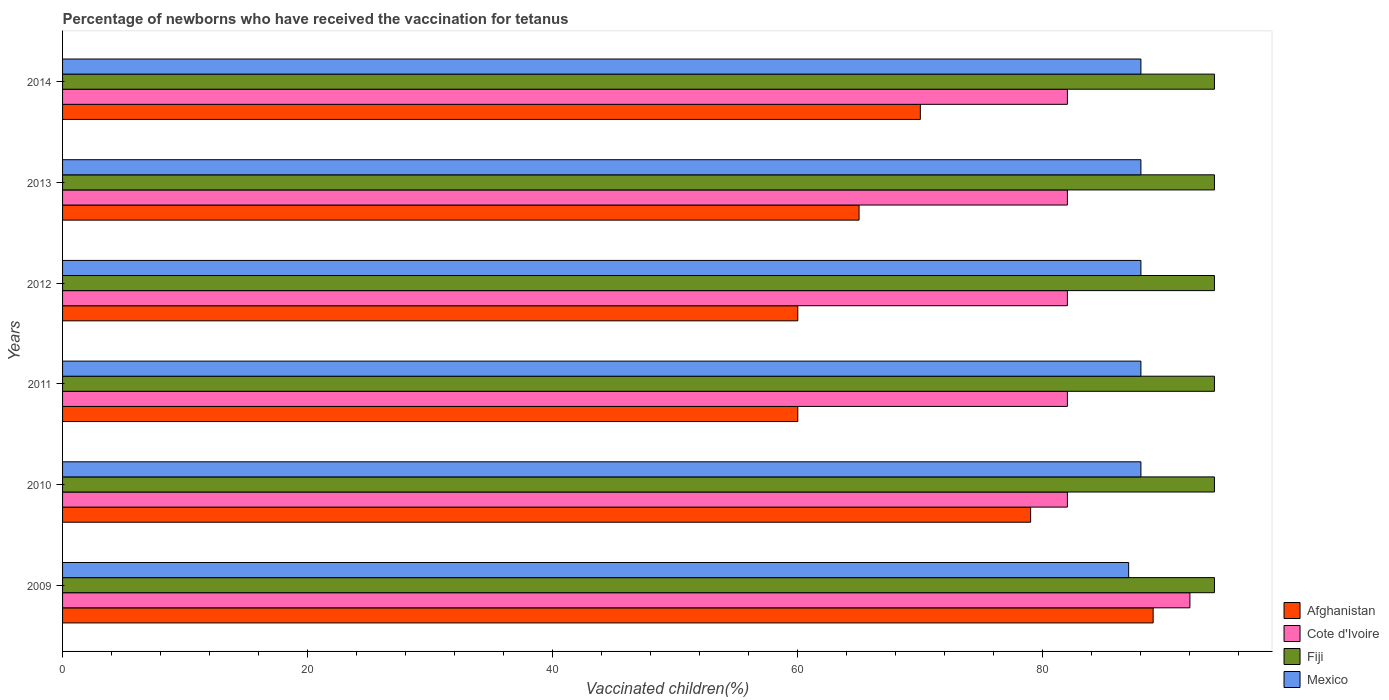What is the label of the 3rd group of bars from the top?
Give a very brief answer. 2012. What is the percentage of vaccinated children in Cote d'Ivoire in 2011?
Your response must be concise. 82. Across all years, what is the maximum percentage of vaccinated children in Cote d'Ivoire?
Keep it short and to the point. 92. What is the total percentage of vaccinated children in Mexico in the graph?
Provide a short and direct response. 527. What is the difference between the percentage of vaccinated children in Cote d'Ivoire in 2010 and that in 2012?
Give a very brief answer. 0. What is the difference between the percentage of vaccinated children in Cote d'Ivoire in 2014 and the percentage of vaccinated children in Mexico in 2013?
Make the answer very short. -6. What is the average percentage of vaccinated children in Afghanistan per year?
Your answer should be very brief. 70.5. In how many years, is the percentage of vaccinated children in Mexico greater than 64 %?
Provide a succinct answer. 6. What is the ratio of the percentage of vaccinated children in Mexico in 2009 to that in 2012?
Your response must be concise. 0.99. Is the percentage of vaccinated children in Fiji in 2009 less than that in 2011?
Make the answer very short. No. Is the difference between the percentage of vaccinated children in Afghanistan in 2010 and 2014 greater than the difference between the percentage of vaccinated children in Fiji in 2010 and 2014?
Provide a succinct answer. Yes. What is the difference between the highest and the second highest percentage of vaccinated children in Mexico?
Your answer should be compact. 0. Is the sum of the percentage of vaccinated children in Cote d'Ivoire in 2012 and 2013 greater than the maximum percentage of vaccinated children in Afghanistan across all years?
Your response must be concise. Yes. What does the 2nd bar from the top in 2009 represents?
Your response must be concise. Fiji. What does the 2nd bar from the bottom in 2013 represents?
Make the answer very short. Cote d'Ivoire. Are the values on the major ticks of X-axis written in scientific E-notation?
Keep it short and to the point. No. Does the graph contain any zero values?
Make the answer very short. No. Does the graph contain grids?
Provide a short and direct response. No. How many legend labels are there?
Your answer should be compact. 4. What is the title of the graph?
Offer a terse response. Percentage of newborns who have received the vaccination for tetanus. Does "Equatorial Guinea" appear as one of the legend labels in the graph?
Keep it short and to the point. No. What is the label or title of the X-axis?
Your answer should be very brief. Vaccinated children(%). What is the Vaccinated children(%) in Afghanistan in 2009?
Keep it short and to the point. 89. What is the Vaccinated children(%) in Cote d'Ivoire in 2009?
Give a very brief answer. 92. What is the Vaccinated children(%) in Fiji in 2009?
Give a very brief answer. 94. What is the Vaccinated children(%) of Mexico in 2009?
Your answer should be compact. 87. What is the Vaccinated children(%) in Afghanistan in 2010?
Offer a very short reply. 79. What is the Vaccinated children(%) of Fiji in 2010?
Give a very brief answer. 94. What is the Vaccinated children(%) in Fiji in 2011?
Your answer should be very brief. 94. What is the Vaccinated children(%) of Fiji in 2012?
Your answer should be very brief. 94. What is the Vaccinated children(%) in Mexico in 2012?
Make the answer very short. 88. What is the Vaccinated children(%) in Fiji in 2013?
Give a very brief answer. 94. What is the Vaccinated children(%) in Cote d'Ivoire in 2014?
Make the answer very short. 82. What is the Vaccinated children(%) of Fiji in 2014?
Offer a very short reply. 94. What is the Vaccinated children(%) in Mexico in 2014?
Your answer should be very brief. 88. Across all years, what is the maximum Vaccinated children(%) of Afghanistan?
Your answer should be very brief. 89. Across all years, what is the maximum Vaccinated children(%) of Cote d'Ivoire?
Ensure brevity in your answer.  92. Across all years, what is the maximum Vaccinated children(%) in Fiji?
Your response must be concise. 94. Across all years, what is the minimum Vaccinated children(%) in Fiji?
Your response must be concise. 94. Across all years, what is the minimum Vaccinated children(%) in Mexico?
Your answer should be compact. 87. What is the total Vaccinated children(%) of Afghanistan in the graph?
Provide a short and direct response. 423. What is the total Vaccinated children(%) of Cote d'Ivoire in the graph?
Provide a succinct answer. 502. What is the total Vaccinated children(%) of Fiji in the graph?
Make the answer very short. 564. What is the total Vaccinated children(%) of Mexico in the graph?
Give a very brief answer. 527. What is the difference between the Vaccinated children(%) of Afghanistan in 2009 and that in 2010?
Offer a terse response. 10. What is the difference between the Vaccinated children(%) of Fiji in 2009 and that in 2010?
Your answer should be compact. 0. What is the difference between the Vaccinated children(%) of Afghanistan in 2009 and that in 2011?
Offer a terse response. 29. What is the difference between the Vaccinated children(%) in Fiji in 2009 and that in 2011?
Provide a short and direct response. 0. What is the difference between the Vaccinated children(%) in Afghanistan in 2009 and that in 2012?
Make the answer very short. 29. What is the difference between the Vaccinated children(%) of Cote d'Ivoire in 2009 and that in 2012?
Provide a succinct answer. 10. What is the difference between the Vaccinated children(%) in Fiji in 2009 and that in 2013?
Your response must be concise. 0. What is the difference between the Vaccinated children(%) in Mexico in 2009 and that in 2013?
Keep it short and to the point. -1. What is the difference between the Vaccinated children(%) of Afghanistan in 2009 and that in 2014?
Provide a succinct answer. 19. What is the difference between the Vaccinated children(%) in Cote d'Ivoire in 2009 and that in 2014?
Provide a short and direct response. 10. What is the difference between the Vaccinated children(%) of Fiji in 2009 and that in 2014?
Give a very brief answer. 0. What is the difference between the Vaccinated children(%) in Cote d'Ivoire in 2010 and that in 2011?
Provide a succinct answer. 0. What is the difference between the Vaccinated children(%) in Fiji in 2010 and that in 2011?
Provide a succinct answer. 0. What is the difference between the Vaccinated children(%) of Mexico in 2010 and that in 2011?
Provide a short and direct response. 0. What is the difference between the Vaccinated children(%) of Mexico in 2010 and that in 2012?
Make the answer very short. 0. What is the difference between the Vaccinated children(%) of Afghanistan in 2010 and that in 2013?
Ensure brevity in your answer.  14. What is the difference between the Vaccinated children(%) of Fiji in 2010 and that in 2013?
Offer a very short reply. 0. What is the difference between the Vaccinated children(%) in Mexico in 2010 and that in 2013?
Provide a short and direct response. 0. What is the difference between the Vaccinated children(%) in Fiji in 2010 and that in 2014?
Offer a terse response. 0. What is the difference between the Vaccinated children(%) of Afghanistan in 2011 and that in 2012?
Ensure brevity in your answer.  0. What is the difference between the Vaccinated children(%) of Fiji in 2011 and that in 2012?
Your answer should be very brief. 0. What is the difference between the Vaccinated children(%) of Mexico in 2011 and that in 2012?
Offer a terse response. 0. What is the difference between the Vaccinated children(%) in Cote d'Ivoire in 2011 and that in 2013?
Keep it short and to the point. 0. What is the difference between the Vaccinated children(%) of Fiji in 2011 and that in 2013?
Your answer should be compact. 0. What is the difference between the Vaccinated children(%) in Mexico in 2011 and that in 2013?
Make the answer very short. 0. What is the difference between the Vaccinated children(%) in Cote d'Ivoire in 2011 and that in 2014?
Offer a terse response. 0. What is the difference between the Vaccinated children(%) in Fiji in 2011 and that in 2014?
Ensure brevity in your answer.  0. What is the difference between the Vaccinated children(%) in Mexico in 2011 and that in 2014?
Your answer should be very brief. 0. What is the difference between the Vaccinated children(%) in Afghanistan in 2012 and that in 2013?
Make the answer very short. -5. What is the difference between the Vaccinated children(%) in Mexico in 2012 and that in 2013?
Provide a short and direct response. 0. What is the difference between the Vaccinated children(%) of Afghanistan in 2012 and that in 2014?
Your answer should be very brief. -10. What is the difference between the Vaccinated children(%) of Fiji in 2012 and that in 2014?
Your response must be concise. 0. What is the difference between the Vaccinated children(%) in Mexico in 2012 and that in 2014?
Keep it short and to the point. 0. What is the difference between the Vaccinated children(%) in Cote d'Ivoire in 2013 and that in 2014?
Offer a very short reply. 0. What is the difference between the Vaccinated children(%) in Afghanistan in 2009 and the Vaccinated children(%) in Cote d'Ivoire in 2010?
Offer a very short reply. 7. What is the difference between the Vaccinated children(%) of Afghanistan in 2009 and the Vaccinated children(%) of Mexico in 2010?
Keep it short and to the point. 1. What is the difference between the Vaccinated children(%) of Cote d'Ivoire in 2009 and the Vaccinated children(%) of Mexico in 2010?
Offer a terse response. 4. What is the difference between the Vaccinated children(%) of Afghanistan in 2009 and the Vaccinated children(%) of Cote d'Ivoire in 2011?
Provide a short and direct response. 7. What is the difference between the Vaccinated children(%) of Cote d'Ivoire in 2009 and the Vaccinated children(%) of Mexico in 2011?
Make the answer very short. 4. What is the difference between the Vaccinated children(%) of Fiji in 2009 and the Vaccinated children(%) of Mexico in 2011?
Make the answer very short. 6. What is the difference between the Vaccinated children(%) of Afghanistan in 2009 and the Vaccinated children(%) of Cote d'Ivoire in 2012?
Ensure brevity in your answer.  7. What is the difference between the Vaccinated children(%) of Afghanistan in 2009 and the Vaccinated children(%) of Fiji in 2012?
Provide a succinct answer. -5. What is the difference between the Vaccinated children(%) of Afghanistan in 2009 and the Vaccinated children(%) of Mexico in 2012?
Your response must be concise. 1. What is the difference between the Vaccinated children(%) in Cote d'Ivoire in 2009 and the Vaccinated children(%) in Fiji in 2012?
Ensure brevity in your answer.  -2. What is the difference between the Vaccinated children(%) in Fiji in 2009 and the Vaccinated children(%) in Mexico in 2012?
Your response must be concise. 6. What is the difference between the Vaccinated children(%) of Afghanistan in 2009 and the Vaccinated children(%) of Cote d'Ivoire in 2013?
Keep it short and to the point. 7. What is the difference between the Vaccinated children(%) of Cote d'Ivoire in 2009 and the Vaccinated children(%) of Mexico in 2013?
Provide a short and direct response. 4. What is the difference between the Vaccinated children(%) of Afghanistan in 2009 and the Vaccinated children(%) of Fiji in 2014?
Ensure brevity in your answer.  -5. What is the difference between the Vaccinated children(%) of Cote d'Ivoire in 2009 and the Vaccinated children(%) of Fiji in 2014?
Provide a short and direct response. -2. What is the difference between the Vaccinated children(%) of Fiji in 2009 and the Vaccinated children(%) of Mexico in 2014?
Ensure brevity in your answer.  6. What is the difference between the Vaccinated children(%) in Afghanistan in 2010 and the Vaccinated children(%) in Cote d'Ivoire in 2011?
Make the answer very short. -3. What is the difference between the Vaccinated children(%) of Afghanistan in 2010 and the Vaccinated children(%) of Mexico in 2012?
Make the answer very short. -9. What is the difference between the Vaccinated children(%) of Cote d'Ivoire in 2010 and the Vaccinated children(%) of Fiji in 2012?
Keep it short and to the point. -12. What is the difference between the Vaccinated children(%) in Cote d'Ivoire in 2010 and the Vaccinated children(%) in Mexico in 2012?
Ensure brevity in your answer.  -6. What is the difference between the Vaccinated children(%) of Afghanistan in 2010 and the Vaccinated children(%) of Fiji in 2013?
Provide a short and direct response. -15. What is the difference between the Vaccinated children(%) in Cote d'Ivoire in 2010 and the Vaccinated children(%) in Fiji in 2013?
Ensure brevity in your answer.  -12. What is the difference between the Vaccinated children(%) of Cote d'Ivoire in 2010 and the Vaccinated children(%) of Mexico in 2013?
Make the answer very short. -6. What is the difference between the Vaccinated children(%) of Fiji in 2010 and the Vaccinated children(%) of Mexico in 2013?
Your answer should be compact. 6. What is the difference between the Vaccinated children(%) of Afghanistan in 2010 and the Vaccinated children(%) of Cote d'Ivoire in 2014?
Keep it short and to the point. -3. What is the difference between the Vaccinated children(%) in Afghanistan in 2010 and the Vaccinated children(%) in Fiji in 2014?
Your answer should be compact. -15. What is the difference between the Vaccinated children(%) in Afghanistan in 2010 and the Vaccinated children(%) in Mexico in 2014?
Offer a very short reply. -9. What is the difference between the Vaccinated children(%) of Cote d'Ivoire in 2010 and the Vaccinated children(%) of Fiji in 2014?
Your response must be concise. -12. What is the difference between the Vaccinated children(%) in Fiji in 2010 and the Vaccinated children(%) in Mexico in 2014?
Ensure brevity in your answer.  6. What is the difference between the Vaccinated children(%) of Afghanistan in 2011 and the Vaccinated children(%) of Fiji in 2012?
Provide a succinct answer. -34. What is the difference between the Vaccinated children(%) in Afghanistan in 2011 and the Vaccinated children(%) in Mexico in 2012?
Offer a terse response. -28. What is the difference between the Vaccinated children(%) in Cote d'Ivoire in 2011 and the Vaccinated children(%) in Fiji in 2012?
Offer a terse response. -12. What is the difference between the Vaccinated children(%) of Fiji in 2011 and the Vaccinated children(%) of Mexico in 2012?
Your response must be concise. 6. What is the difference between the Vaccinated children(%) of Afghanistan in 2011 and the Vaccinated children(%) of Fiji in 2013?
Ensure brevity in your answer.  -34. What is the difference between the Vaccinated children(%) in Afghanistan in 2011 and the Vaccinated children(%) in Mexico in 2013?
Offer a very short reply. -28. What is the difference between the Vaccinated children(%) of Cote d'Ivoire in 2011 and the Vaccinated children(%) of Fiji in 2013?
Provide a short and direct response. -12. What is the difference between the Vaccinated children(%) in Cote d'Ivoire in 2011 and the Vaccinated children(%) in Mexico in 2013?
Provide a short and direct response. -6. What is the difference between the Vaccinated children(%) in Fiji in 2011 and the Vaccinated children(%) in Mexico in 2013?
Offer a very short reply. 6. What is the difference between the Vaccinated children(%) in Afghanistan in 2011 and the Vaccinated children(%) in Cote d'Ivoire in 2014?
Your answer should be compact. -22. What is the difference between the Vaccinated children(%) of Afghanistan in 2011 and the Vaccinated children(%) of Fiji in 2014?
Your answer should be compact. -34. What is the difference between the Vaccinated children(%) of Afghanistan in 2011 and the Vaccinated children(%) of Mexico in 2014?
Your response must be concise. -28. What is the difference between the Vaccinated children(%) in Cote d'Ivoire in 2011 and the Vaccinated children(%) in Mexico in 2014?
Offer a terse response. -6. What is the difference between the Vaccinated children(%) of Fiji in 2011 and the Vaccinated children(%) of Mexico in 2014?
Offer a very short reply. 6. What is the difference between the Vaccinated children(%) in Afghanistan in 2012 and the Vaccinated children(%) in Cote d'Ivoire in 2013?
Make the answer very short. -22. What is the difference between the Vaccinated children(%) in Afghanistan in 2012 and the Vaccinated children(%) in Fiji in 2013?
Your response must be concise. -34. What is the difference between the Vaccinated children(%) in Afghanistan in 2012 and the Vaccinated children(%) in Mexico in 2013?
Keep it short and to the point. -28. What is the difference between the Vaccinated children(%) in Afghanistan in 2012 and the Vaccinated children(%) in Fiji in 2014?
Provide a short and direct response. -34. What is the difference between the Vaccinated children(%) of Afghanistan in 2012 and the Vaccinated children(%) of Mexico in 2014?
Ensure brevity in your answer.  -28. What is the difference between the Vaccinated children(%) in Cote d'Ivoire in 2012 and the Vaccinated children(%) in Fiji in 2014?
Your response must be concise. -12. What is the difference between the Vaccinated children(%) in Fiji in 2012 and the Vaccinated children(%) in Mexico in 2014?
Provide a short and direct response. 6. What is the difference between the Vaccinated children(%) of Afghanistan in 2013 and the Vaccinated children(%) of Fiji in 2014?
Offer a very short reply. -29. What is the difference between the Vaccinated children(%) of Fiji in 2013 and the Vaccinated children(%) of Mexico in 2014?
Offer a terse response. 6. What is the average Vaccinated children(%) of Afghanistan per year?
Provide a succinct answer. 70.5. What is the average Vaccinated children(%) of Cote d'Ivoire per year?
Provide a succinct answer. 83.67. What is the average Vaccinated children(%) of Fiji per year?
Ensure brevity in your answer.  94. What is the average Vaccinated children(%) in Mexico per year?
Keep it short and to the point. 87.83. In the year 2009, what is the difference between the Vaccinated children(%) in Afghanistan and Vaccinated children(%) in Fiji?
Offer a terse response. -5. In the year 2009, what is the difference between the Vaccinated children(%) in Cote d'Ivoire and Vaccinated children(%) in Fiji?
Give a very brief answer. -2. In the year 2009, what is the difference between the Vaccinated children(%) in Cote d'Ivoire and Vaccinated children(%) in Mexico?
Keep it short and to the point. 5. In the year 2009, what is the difference between the Vaccinated children(%) of Fiji and Vaccinated children(%) of Mexico?
Give a very brief answer. 7. In the year 2010, what is the difference between the Vaccinated children(%) of Afghanistan and Vaccinated children(%) of Fiji?
Offer a very short reply. -15. In the year 2010, what is the difference between the Vaccinated children(%) of Cote d'Ivoire and Vaccinated children(%) of Fiji?
Your answer should be compact. -12. In the year 2010, what is the difference between the Vaccinated children(%) in Cote d'Ivoire and Vaccinated children(%) in Mexico?
Make the answer very short. -6. In the year 2011, what is the difference between the Vaccinated children(%) in Afghanistan and Vaccinated children(%) in Cote d'Ivoire?
Your answer should be very brief. -22. In the year 2011, what is the difference between the Vaccinated children(%) in Afghanistan and Vaccinated children(%) in Fiji?
Your response must be concise. -34. In the year 2011, what is the difference between the Vaccinated children(%) of Fiji and Vaccinated children(%) of Mexico?
Your response must be concise. 6. In the year 2012, what is the difference between the Vaccinated children(%) of Afghanistan and Vaccinated children(%) of Fiji?
Your response must be concise. -34. In the year 2012, what is the difference between the Vaccinated children(%) of Afghanistan and Vaccinated children(%) of Mexico?
Make the answer very short. -28. In the year 2012, what is the difference between the Vaccinated children(%) of Cote d'Ivoire and Vaccinated children(%) of Fiji?
Your answer should be very brief. -12. In the year 2013, what is the difference between the Vaccinated children(%) of Afghanistan and Vaccinated children(%) of Fiji?
Your answer should be compact. -29. In the year 2013, what is the difference between the Vaccinated children(%) of Afghanistan and Vaccinated children(%) of Mexico?
Provide a succinct answer. -23. In the year 2013, what is the difference between the Vaccinated children(%) in Cote d'Ivoire and Vaccinated children(%) in Mexico?
Make the answer very short. -6. In the year 2013, what is the difference between the Vaccinated children(%) of Fiji and Vaccinated children(%) of Mexico?
Provide a succinct answer. 6. In the year 2014, what is the difference between the Vaccinated children(%) in Cote d'Ivoire and Vaccinated children(%) in Fiji?
Ensure brevity in your answer.  -12. What is the ratio of the Vaccinated children(%) in Afghanistan in 2009 to that in 2010?
Your answer should be compact. 1.13. What is the ratio of the Vaccinated children(%) of Cote d'Ivoire in 2009 to that in 2010?
Offer a very short reply. 1.12. What is the ratio of the Vaccinated children(%) in Mexico in 2009 to that in 2010?
Your answer should be compact. 0.99. What is the ratio of the Vaccinated children(%) of Afghanistan in 2009 to that in 2011?
Offer a terse response. 1.48. What is the ratio of the Vaccinated children(%) in Cote d'Ivoire in 2009 to that in 2011?
Your response must be concise. 1.12. What is the ratio of the Vaccinated children(%) in Fiji in 2009 to that in 2011?
Your answer should be compact. 1. What is the ratio of the Vaccinated children(%) in Mexico in 2009 to that in 2011?
Your answer should be compact. 0.99. What is the ratio of the Vaccinated children(%) of Afghanistan in 2009 to that in 2012?
Give a very brief answer. 1.48. What is the ratio of the Vaccinated children(%) of Cote d'Ivoire in 2009 to that in 2012?
Make the answer very short. 1.12. What is the ratio of the Vaccinated children(%) of Fiji in 2009 to that in 2012?
Offer a very short reply. 1. What is the ratio of the Vaccinated children(%) in Mexico in 2009 to that in 2012?
Offer a terse response. 0.99. What is the ratio of the Vaccinated children(%) in Afghanistan in 2009 to that in 2013?
Your response must be concise. 1.37. What is the ratio of the Vaccinated children(%) of Cote d'Ivoire in 2009 to that in 2013?
Ensure brevity in your answer.  1.12. What is the ratio of the Vaccinated children(%) in Fiji in 2009 to that in 2013?
Your response must be concise. 1. What is the ratio of the Vaccinated children(%) of Mexico in 2009 to that in 2013?
Your response must be concise. 0.99. What is the ratio of the Vaccinated children(%) in Afghanistan in 2009 to that in 2014?
Provide a short and direct response. 1.27. What is the ratio of the Vaccinated children(%) of Cote d'Ivoire in 2009 to that in 2014?
Ensure brevity in your answer.  1.12. What is the ratio of the Vaccinated children(%) in Afghanistan in 2010 to that in 2011?
Provide a succinct answer. 1.32. What is the ratio of the Vaccinated children(%) of Cote d'Ivoire in 2010 to that in 2011?
Your answer should be very brief. 1. What is the ratio of the Vaccinated children(%) of Fiji in 2010 to that in 2011?
Offer a very short reply. 1. What is the ratio of the Vaccinated children(%) in Afghanistan in 2010 to that in 2012?
Keep it short and to the point. 1.32. What is the ratio of the Vaccinated children(%) of Cote d'Ivoire in 2010 to that in 2012?
Your response must be concise. 1. What is the ratio of the Vaccinated children(%) of Afghanistan in 2010 to that in 2013?
Offer a terse response. 1.22. What is the ratio of the Vaccinated children(%) of Fiji in 2010 to that in 2013?
Your answer should be compact. 1. What is the ratio of the Vaccinated children(%) of Afghanistan in 2010 to that in 2014?
Keep it short and to the point. 1.13. What is the ratio of the Vaccinated children(%) in Cote d'Ivoire in 2010 to that in 2014?
Ensure brevity in your answer.  1. What is the ratio of the Vaccinated children(%) of Mexico in 2010 to that in 2014?
Your response must be concise. 1. What is the ratio of the Vaccinated children(%) in Afghanistan in 2011 to that in 2012?
Offer a terse response. 1. What is the ratio of the Vaccinated children(%) of Afghanistan in 2011 to that in 2013?
Ensure brevity in your answer.  0.92. What is the ratio of the Vaccinated children(%) in Mexico in 2011 to that in 2013?
Your response must be concise. 1. What is the ratio of the Vaccinated children(%) of Mexico in 2011 to that in 2014?
Give a very brief answer. 1. What is the ratio of the Vaccinated children(%) of Fiji in 2012 to that in 2013?
Your answer should be very brief. 1. What is the ratio of the Vaccinated children(%) of Mexico in 2012 to that in 2013?
Ensure brevity in your answer.  1. What is the ratio of the Vaccinated children(%) of Afghanistan in 2012 to that in 2014?
Provide a short and direct response. 0.86. What is the ratio of the Vaccinated children(%) in Fiji in 2012 to that in 2014?
Provide a short and direct response. 1. What is the ratio of the Vaccinated children(%) in Fiji in 2013 to that in 2014?
Ensure brevity in your answer.  1. What is the ratio of the Vaccinated children(%) of Mexico in 2013 to that in 2014?
Your answer should be compact. 1. What is the difference between the highest and the second highest Vaccinated children(%) of Afghanistan?
Offer a terse response. 10. What is the difference between the highest and the second highest Vaccinated children(%) of Fiji?
Your answer should be compact. 0. What is the difference between the highest and the lowest Vaccinated children(%) of Cote d'Ivoire?
Your answer should be compact. 10. 